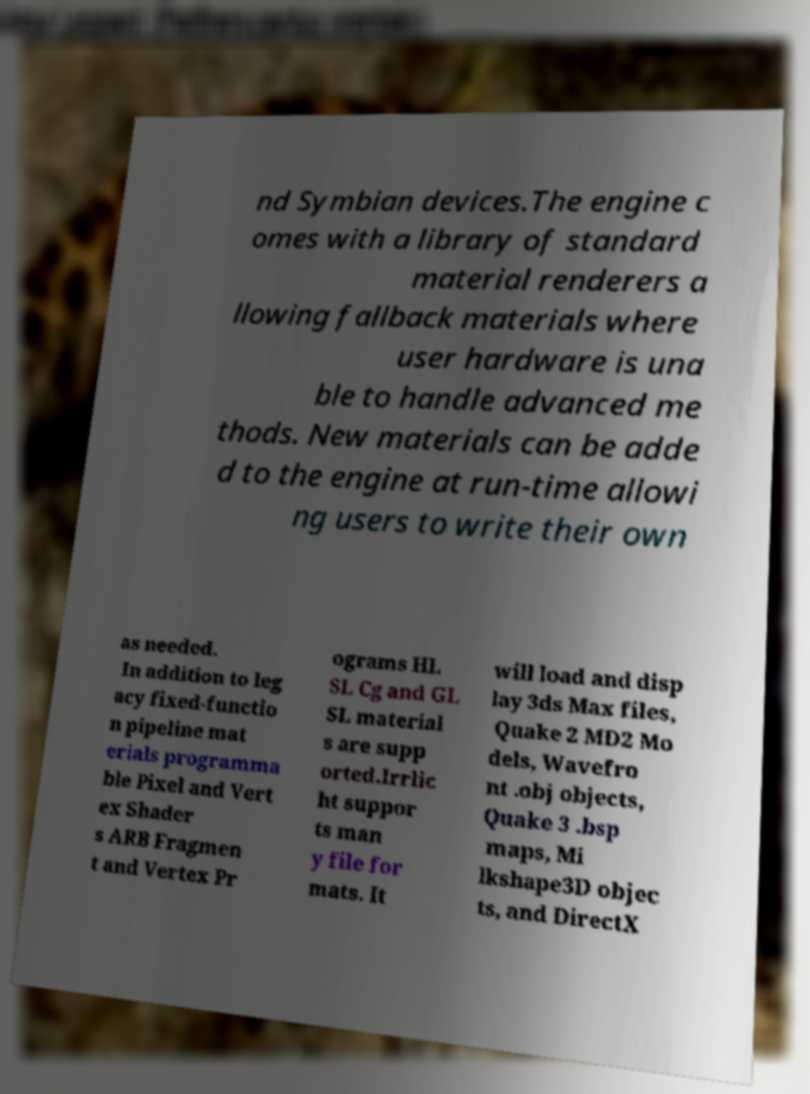There's text embedded in this image that I need extracted. Can you transcribe it verbatim? nd Symbian devices.The engine c omes with a library of standard material renderers a llowing fallback materials where user hardware is una ble to handle advanced me thods. New materials can be adde d to the engine at run-time allowi ng users to write their own as needed. In addition to leg acy fixed-functio n pipeline mat erials programma ble Pixel and Vert ex Shader s ARB Fragmen t and Vertex Pr ograms HL SL Cg and GL SL material s are supp orted.Irrlic ht suppor ts man y file for mats. It will load and disp lay 3ds Max files, Quake 2 MD2 Mo dels, Wavefro nt .obj objects, Quake 3 .bsp maps, Mi lkshape3D objec ts, and DirectX 